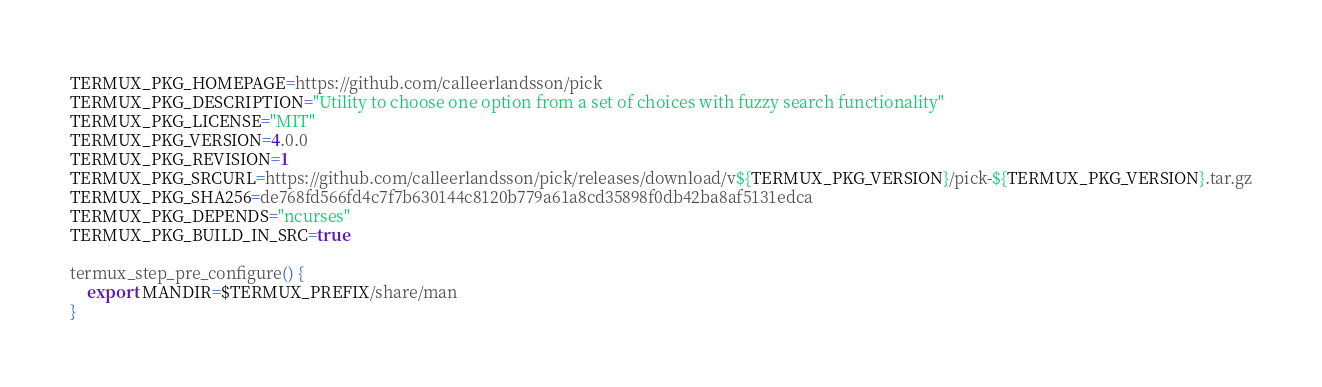Convert code to text. <code><loc_0><loc_0><loc_500><loc_500><_Bash_>TERMUX_PKG_HOMEPAGE=https://github.com/calleerlandsson/pick
TERMUX_PKG_DESCRIPTION="Utility to choose one option from a set of choices with fuzzy search functionality"
TERMUX_PKG_LICENSE="MIT"
TERMUX_PKG_VERSION=4.0.0
TERMUX_PKG_REVISION=1
TERMUX_PKG_SRCURL=https://github.com/calleerlandsson/pick/releases/download/v${TERMUX_PKG_VERSION}/pick-${TERMUX_PKG_VERSION}.tar.gz
TERMUX_PKG_SHA256=de768fd566fd4c7f7b630144c8120b779a61a8cd35898f0db42ba8af5131edca
TERMUX_PKG_DEPENDS="ncurses"
TERMUX_PKG_BUILD_IN_SRC=true

termux_step_pre_configure() {
	export MANDIR=$TERMUX_PREFIX/share/man
}
</code> 